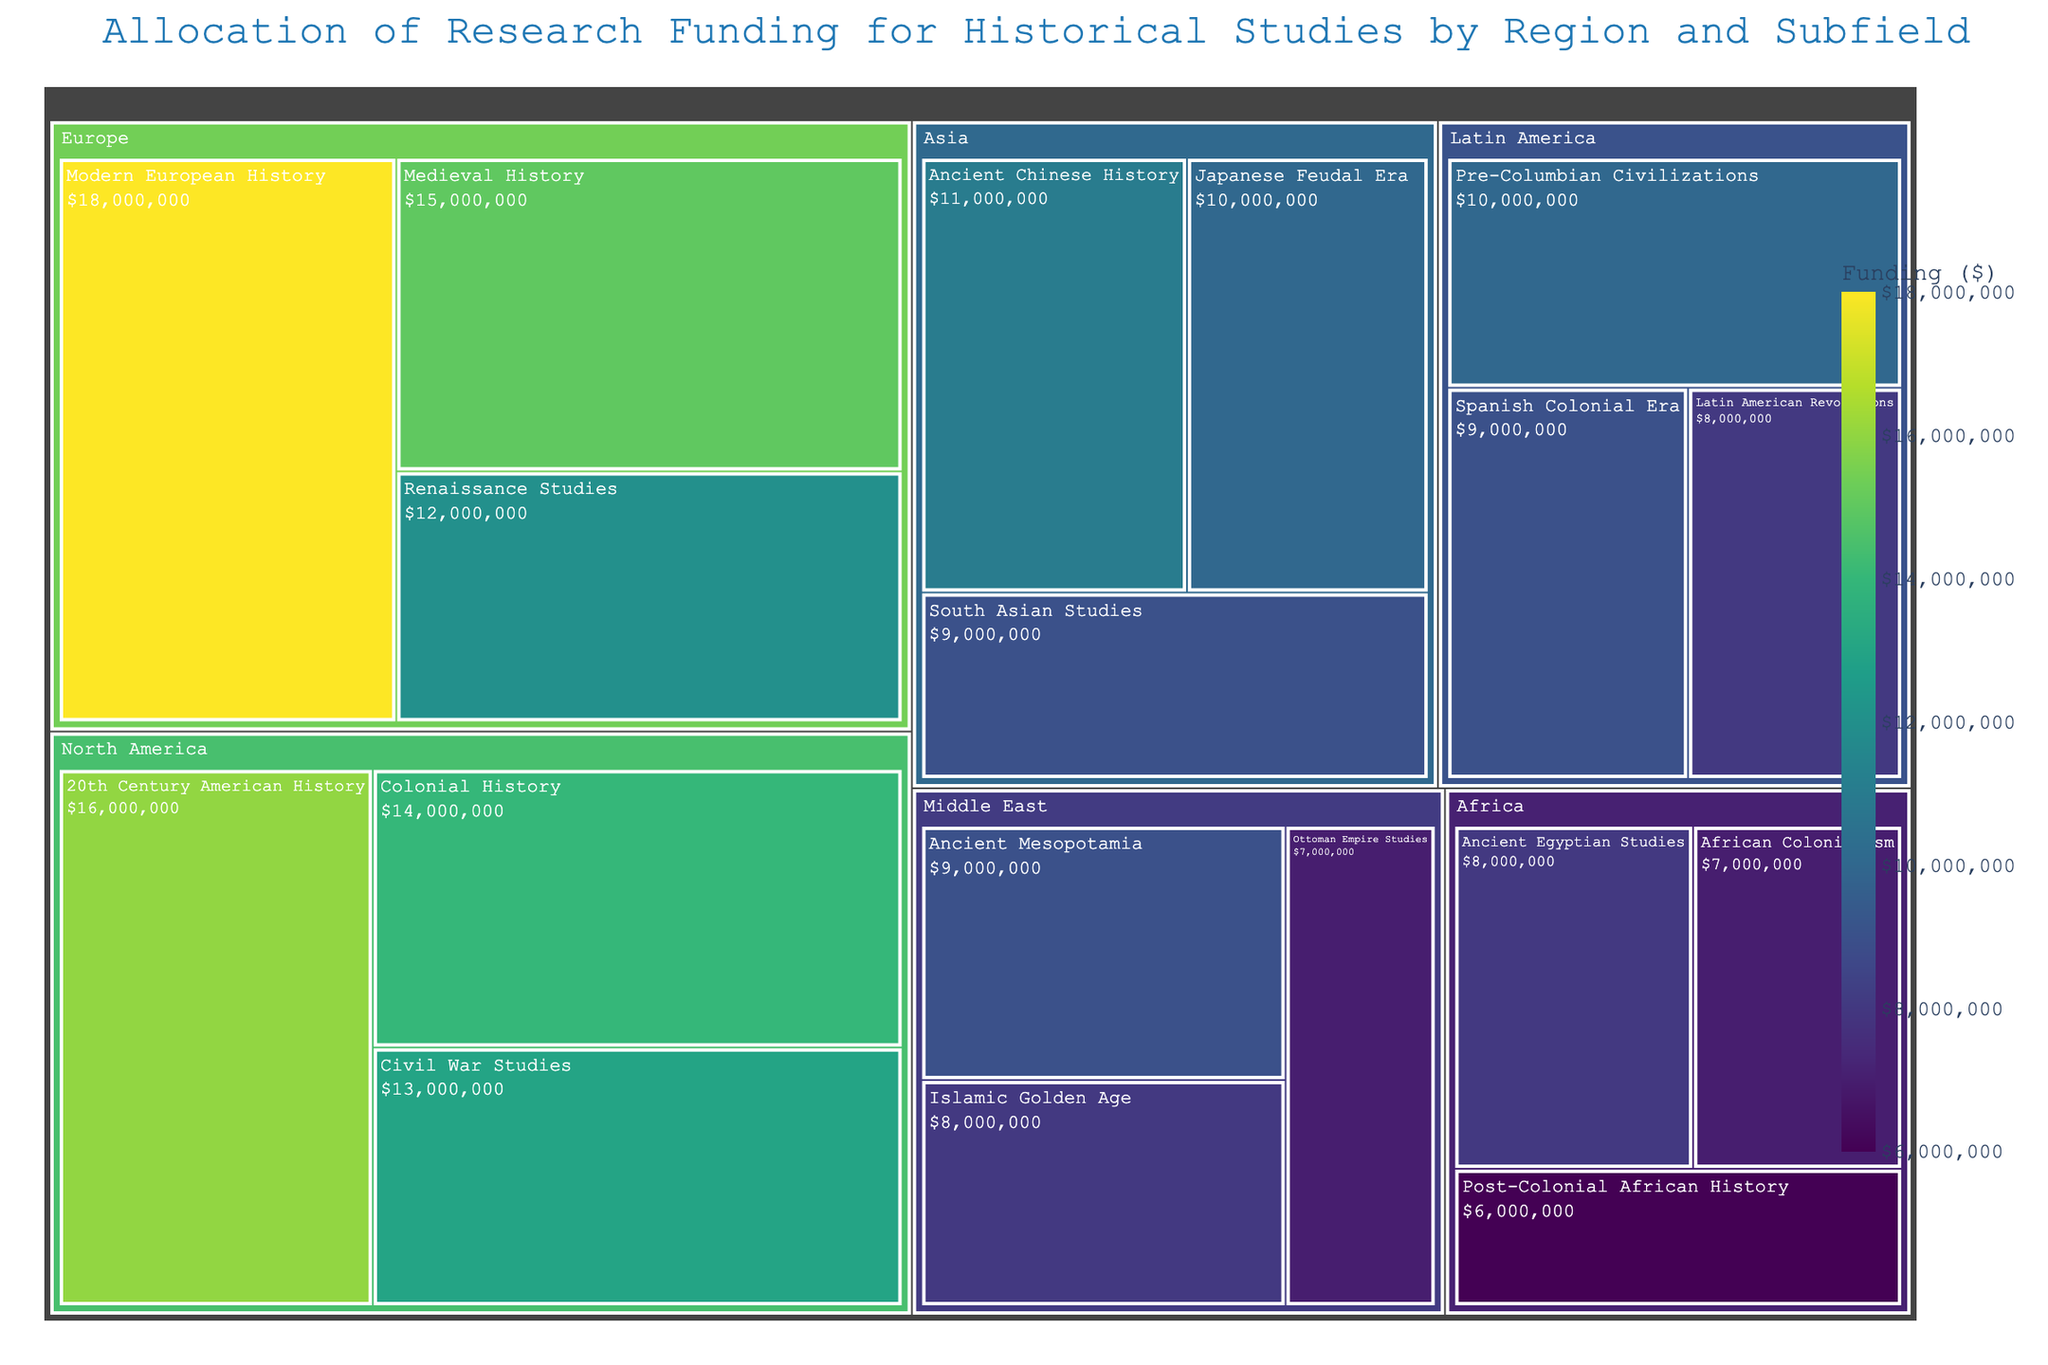How much funding is allocated to Medieval History in Europe? To find the funding allocated to Medieval History in Europe, look at the section labeled "Medieval History" under the "Europe" region. The amount given is $15,000,000.
Answer: $15,000,000 Which subfield in Asia has the lowest funding? For Asia, look at all subfields like Ancient Chinese History, Japanese Feudal Era, and South Asian Studies. The smallest funding amount is for South Asian Studies at $9,000,000.
Answer: South Asian Studies Compare the funding for 20th Century American History in North America with Islamic Golden Age in the Middle East. Which subfield received more funding? Identify the funding for 20th Century American History in North America ($16,000,000) and for Islamic Golden Age in the Middle East ($8,000,000). Comparing the two, 20th Century American History received more funding.
Answer: 20th Century American History What is the total funding allocated for historical studies in Africa? Sum up all the funding amounts for the African subfields: Ancient Egyptian Studies ($8,000,000), African Colonialism ($7,000,000), and Post-Colonial African History ($6,000,000). The total is $8,000,000 + $7,000,000 + $6,000,000 = $21,000,000.
Answer: $21,000,000 Which region has the highest overall research funding? Compare the total funding for each region. Add up the individual subfield funding within each region and see which total is the highest. Europe with sums like Medieval History ($15,000,000), Renaissance Studies ($12,000,000), and Modern European History ($18,000,000) totals $45,000,000, which appears highest.
Answer: Europe Is the funding for Pre-Columbian Civilizations in Latin America greater than for Ottoman Empire Studies in the Middle East? Identify the funding for Pre-Columbian Civilizations in Latin America ($10,000,000) and Ottoman Empire Studies in the Middle East ($7,000,000). Since $10,000,000 is greater than $7,000,000, yes, it is greater.
Answer: Yes What’s the difference in funding between Colonial History in North America and Ancient Chinese History in Asia? Look at the funding for Colonial History in North America ($14,000,000) and for Ancient Chinese History in Asia ($11,000,000). Subtract to find the difference: $14,000,000 - $11,000,000 = $3,000,000.
Answer: $3,000,000 How many subfields have a funding amount of exactly $10,000,000? Look through the treemap for subfields with funding exactly $10,000,000. These are Japanese Feudal Era in Asia and Pre-Columbian Civilizations in Latin America, making it two subfields.
Answer: 2 